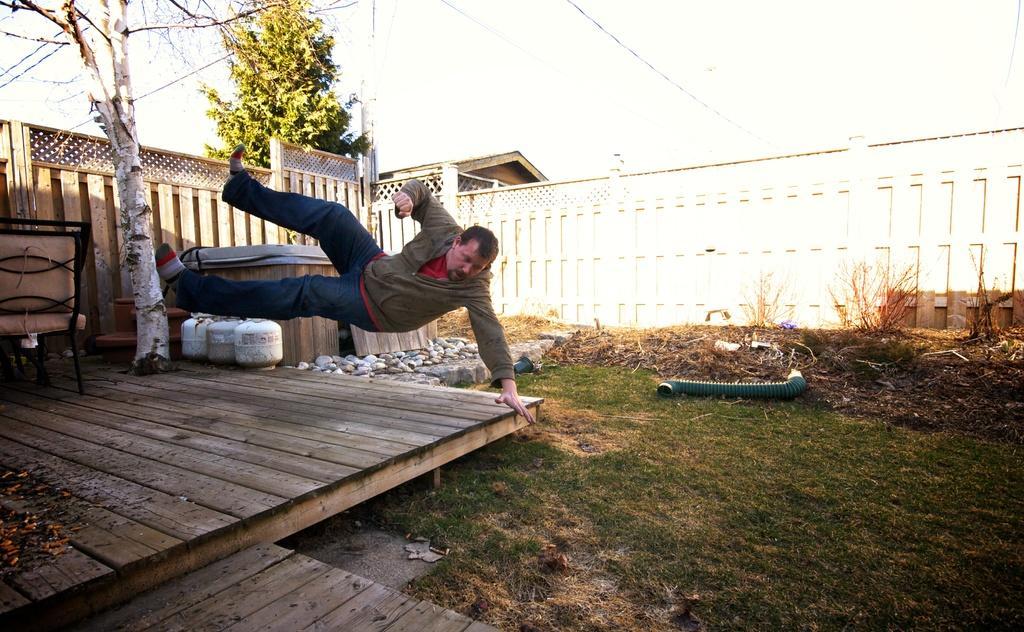Describe this image in one or two sentences. This image is taken outdoors. At the bottom of the image there is a ground with grass on it and there is a wooden platform. In the background there is a wall and there are two trees. On the left side of the image there is an empty chair. In the middle of the image a man jumps on the wooden platform. 